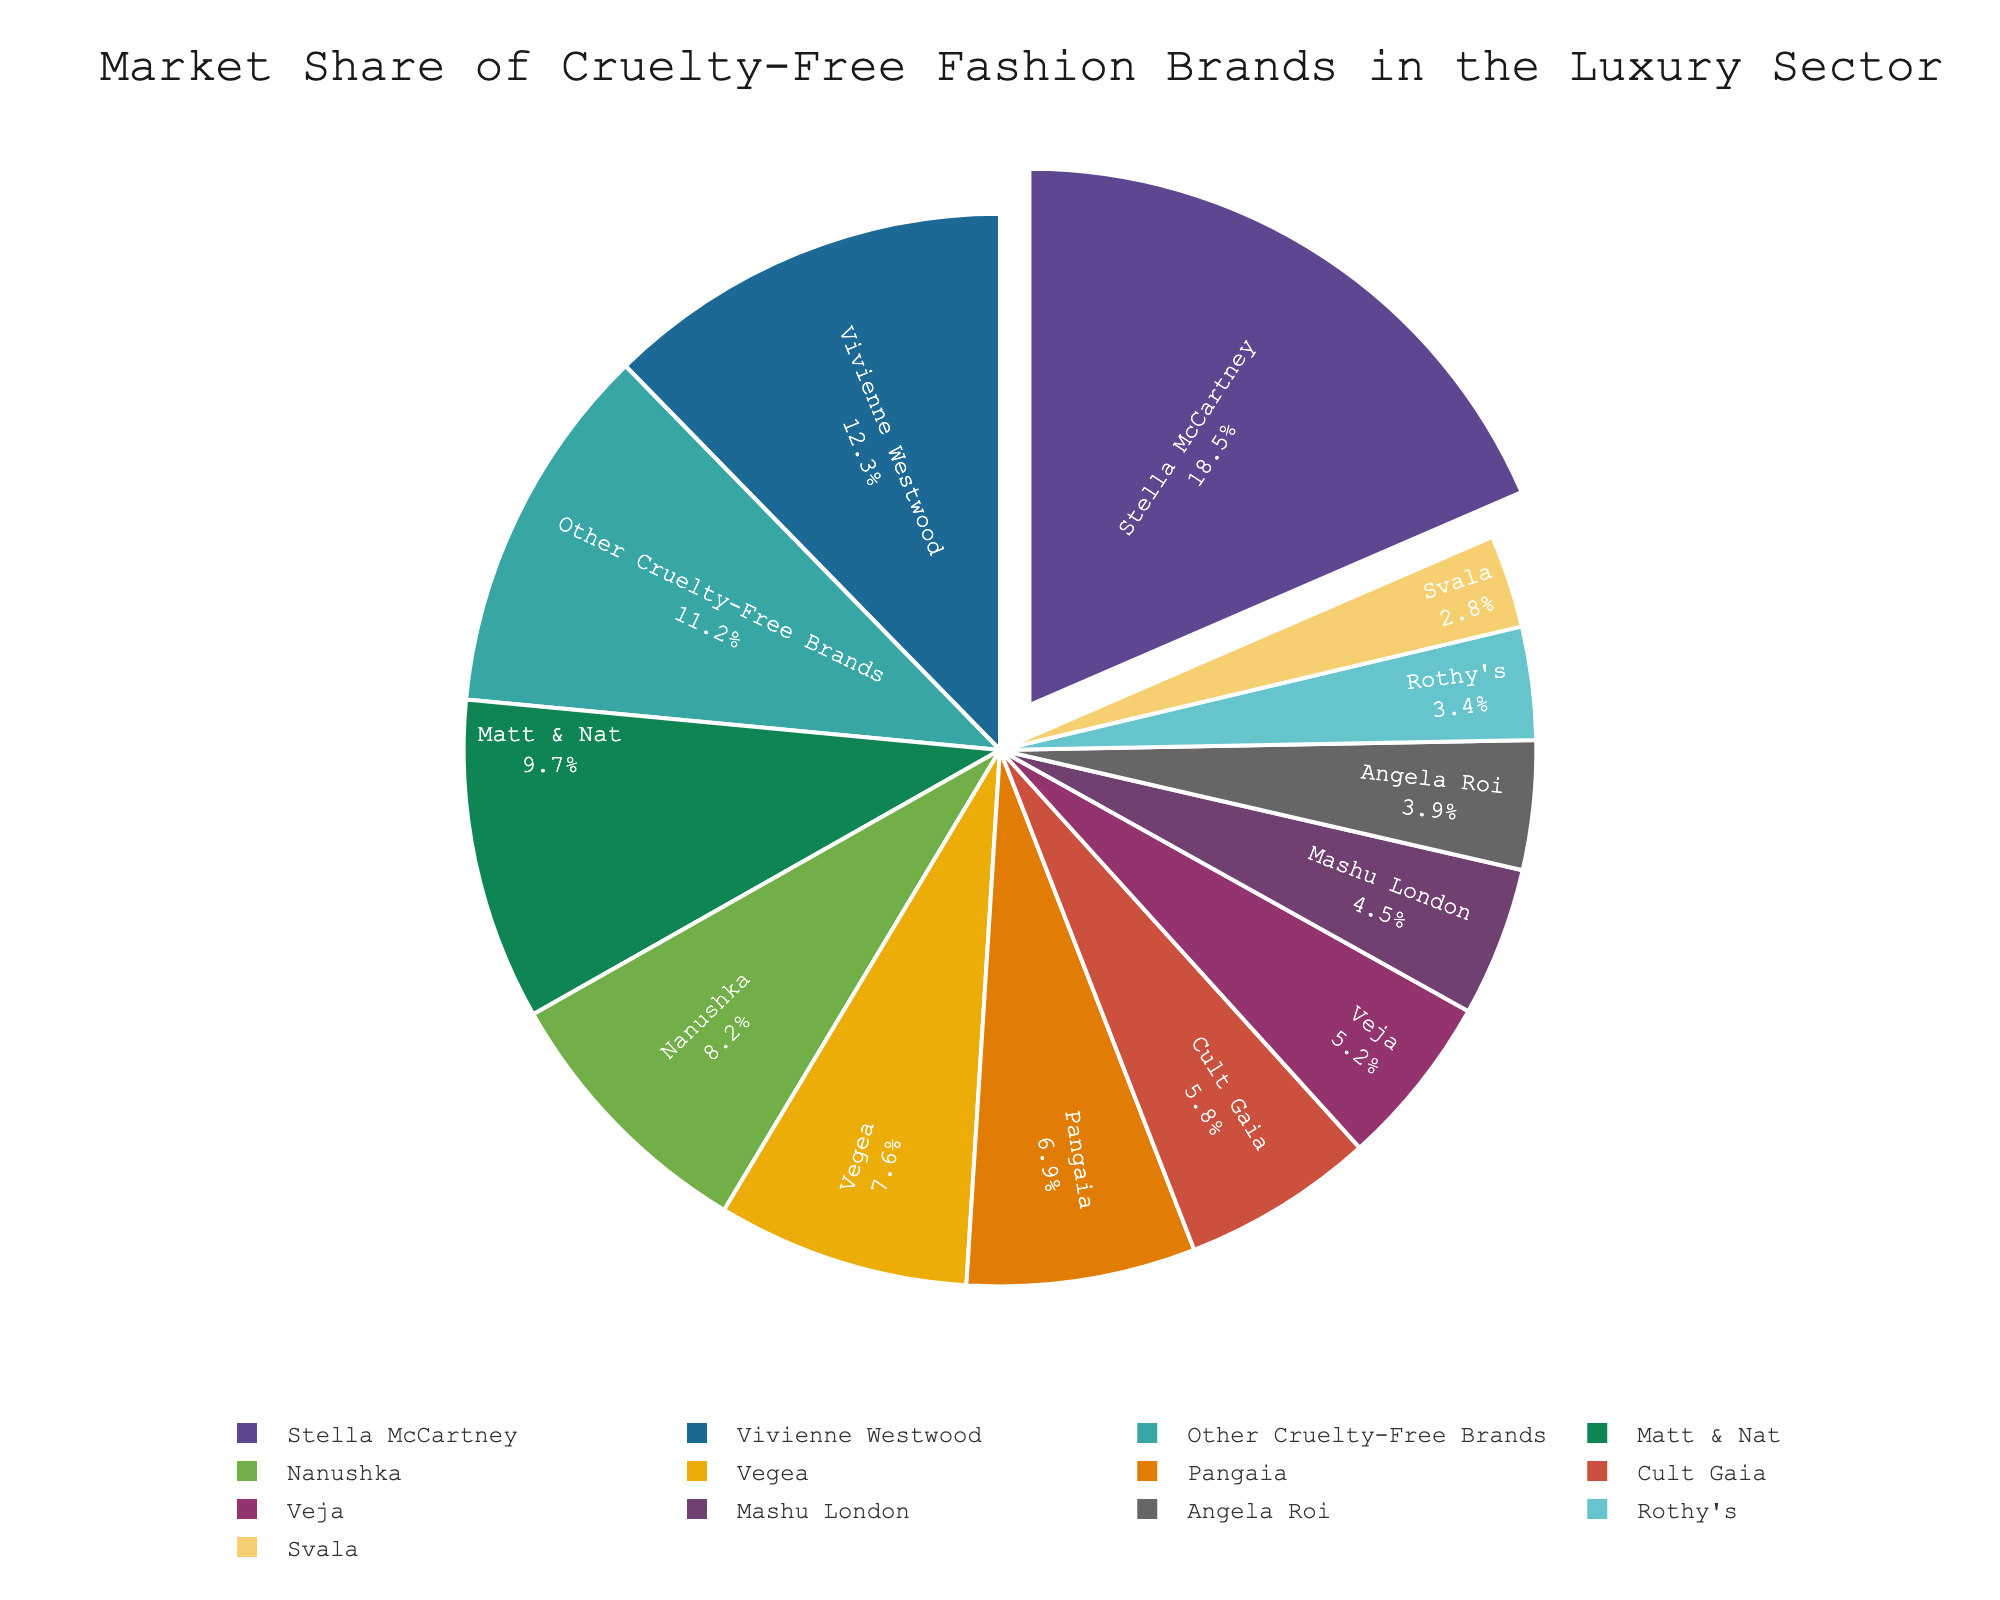What brand holds the largest market share in the luxury sector for cruelty-free fashion? Stella McCartney holds the largest market share. The pie chart highlights this with a pulled-out section and the largest percentage listed.
Answer: Stella McCartney Which brand comes second in terms of market share, and what percentage do they hold? Vivienne Westwood holds the second-largest market share at 12.3%, as indicated by the second-largest section of the pie chart.
Answer: Vivienne Westwood, 12.3% Compare the market shares of Matt & Nat and Nanushka. Which one has a higher share and by how much? Matt & Nat has a market share of 9.7%, and Nanushka has 8.2%. Subtracting these values gives 9.7 - 8.2 = 1.5%.
Answer: Matt & Nat, 1.5% What is the combined market share of Veja and Cult Gaia? Veja has a market share of 5.2%, and Cult Gaia has 5.8%. Adding these values gives 5.2 + 5.8 = 11%.
Answer: 11% Identify brands with a market share less than 5%. List them and their respective percentages. The brands with a market share less than 5% are Mashu London (4.5%), Angela Roi (3.9%), Rothy's (3.4%), and Svala (2.8%).
Answer: Mashu London (4.5%), Angela Roi (3.9%), Rothy's (3.4%), Svala (2.8%) What is the market share difference between Stella McCartney and the sum of the two smallest brands? The market share of Stella McCartney is 18.5%. The two smallest brands are Svala (2.8%) and Rothy's (3.4%). Their combined market share is 2.8 + 3.4 = 6.2%. The difference is 18.5 - 6.2 = 12.3%.
Answer: 12.3% Which brand or group of brands is represented by the 'Other Cruelty-Free Brands' segment, and what is their combined market share? The 'Other Cruelty-Free Brands' segment encompasses smaller brands not individually listed, and their combined market share is 11.2%.
Answer: Other Cruelty-Free Brands, 11.2% Is the market share of Stella McCartney greater than the combined share of Pangaia and Vegea? If so, by how much? Stella McCartney's market share is 18.5%. Pangaia and Vegea have 6.9% and 7.6% respectively, totaling 6.9 + 7.6 = 14.5%. The difference is 18.5 - 14.5 = 4%.
Answer: Yes, 4% Which brand has the least market share, and what is that percentage? Svala has the smallest market share at 2.8%, as shown by the smallest section of the pie chart.
Answer: Svala, 2.8% If you were to combine the market shares of the top three brands, what would their total be? The top three brands are Stella McCartney (18.5%), Vivienne Westwood (12.3%), and Matt & Nat (9.7%). Their total market share is 18.5 + 12.3 + 9.7 = 40.5%.
Answer: 40.5% 